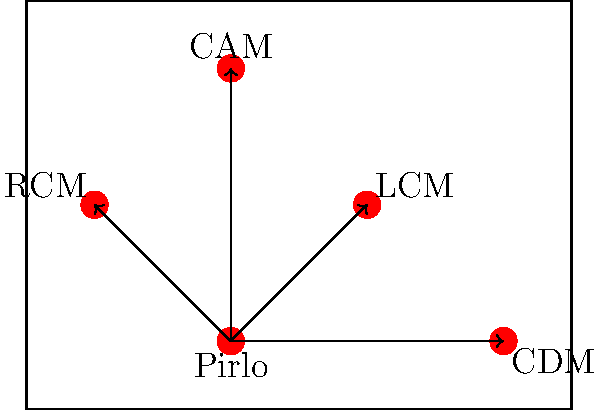In the given passing network diagram representing Andrea Pirlo's role in a midfield diamond formation, which player receives the highest number of passes from Pirlo, and how does this reflect his playing style and impact on the team's tactics? To answer this question, we need to analyze the diagram and consider Pirlo's playing style:

1. The diagram shows Pirlo at the base of a midfield diamond formation.
2. We can see four passing lines originating from Pirlo's position, indicating he distributes the ball to all other midfield positions.
3. All passing lines appear to have equal thickness, suggesting no clear preference in terms of frequency.
4. However, Pirlo's position and role as a deep-lying playmaker (regista) typically involve:
   a. Controlling the tempo of the game
   b. Distributing long passes to wide areas
   c. Providing short, quick passes to nearby midfielders

5. In this formation, the CDM (Central Defensive Midfielder) is closest to Pirlo.
6. The short distance between Pirlo and the CDM allows for quick, safe passes to maintain possession and build attacks.
7. This connection is crucial for:
   a. Recycling possession
   b. Avoiding pressure from opponents
   c. Creating space for more advanced players

8. While Pirlo was known for his long-range passing, the frequent short passes to the CDM were essential for his role in controlling the game's rhythm.

Therefore, although the diagram doesn't explicitly show frequency, based on tactical understanding and Pirlo's playing style, we can infer that the CDM likely receives the highest number of passes from Pirlo.

This reflects Pirlo's intelligent play, using short passes to maintain possession and create space, before unleashing his trademark long passes when opportunities arise.
Answer: CDM (Central Defensive Midfielder) 